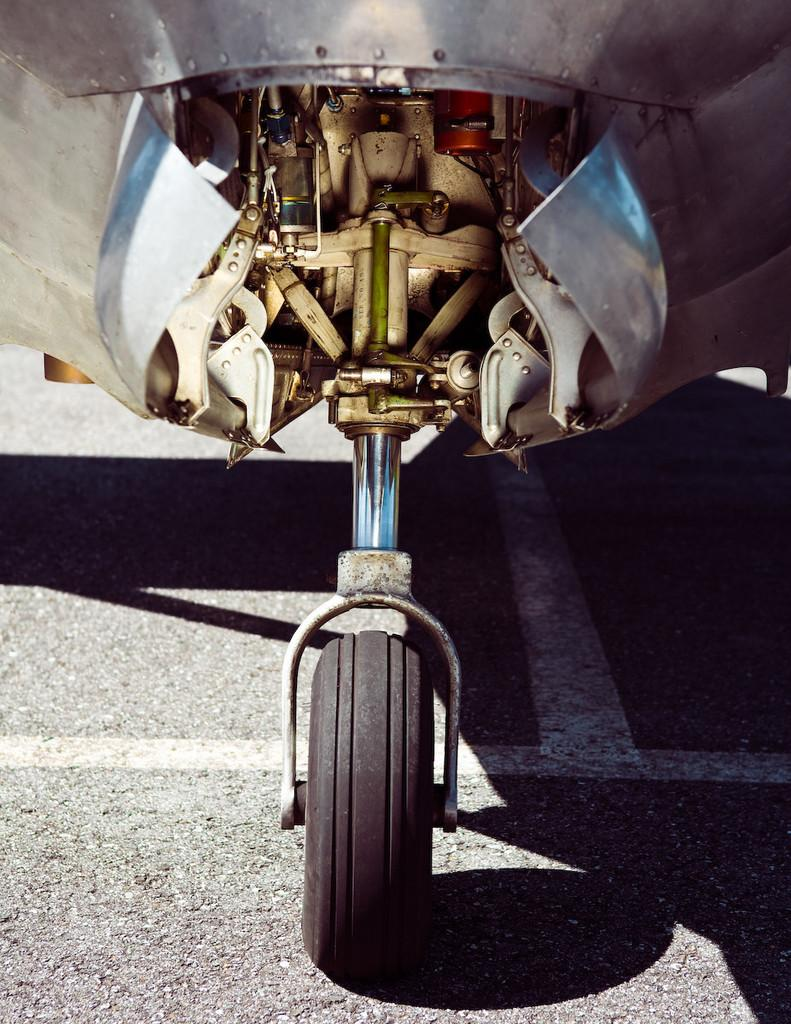What object related to a vehicle can be seen in the image? There is a tire of a vehicle in the image. Can you describe the tire in more detail? The tire appears to be round and made of rubber, as is typical for vehicle tires. What type of fruit is the grandmother feeding to the horse in the image? There is no grandmother, horse, or fruit present in the image; it only features a tire of a vehicle. 